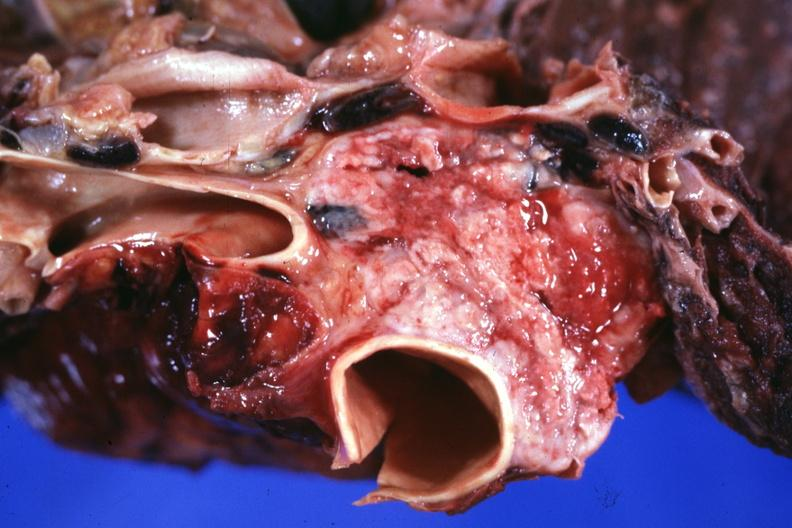what is present?
Answer the question using a single word or phrase. Malignant thymoma 